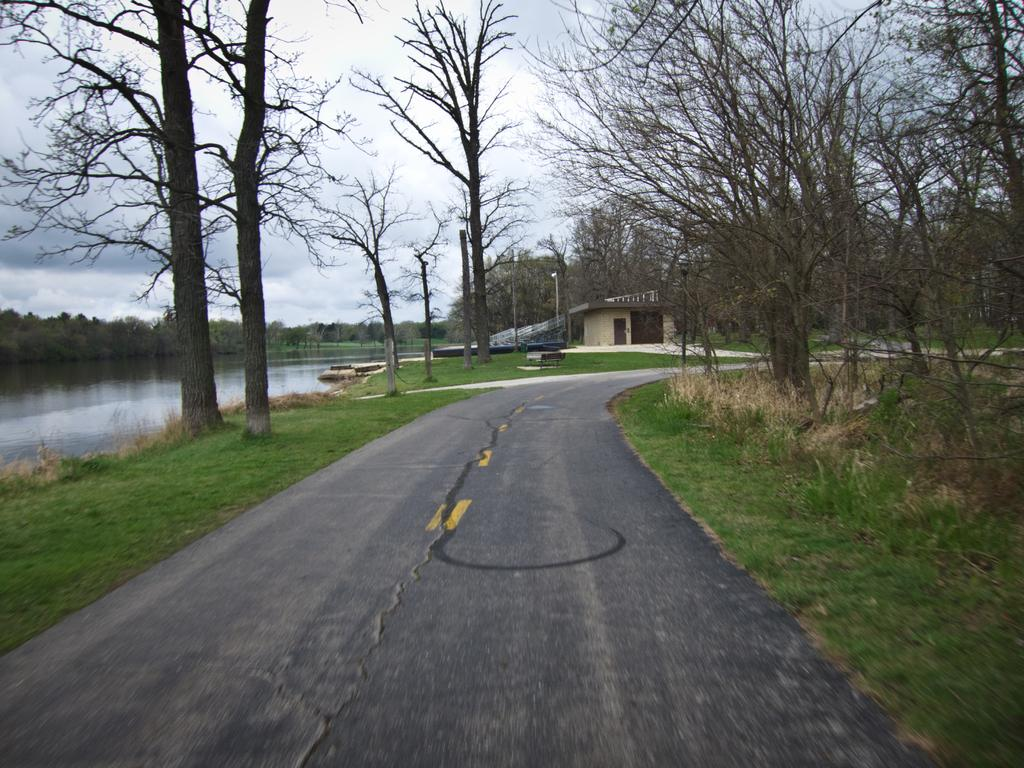What type of surface can be seen in the image? There is a road in the image. What type of vegetation is present in the image? There is grass and dried trees in the image. What can be seen in the background of the image? There is a house, poles, water, trees, and the sky visible in the background of the image. How many cakes are being baked in the image? There are no cakes or baking activities present in the image. What type of growth can be observed on the trees in the image? The trees in the image are dried, so there is no growth visible. 